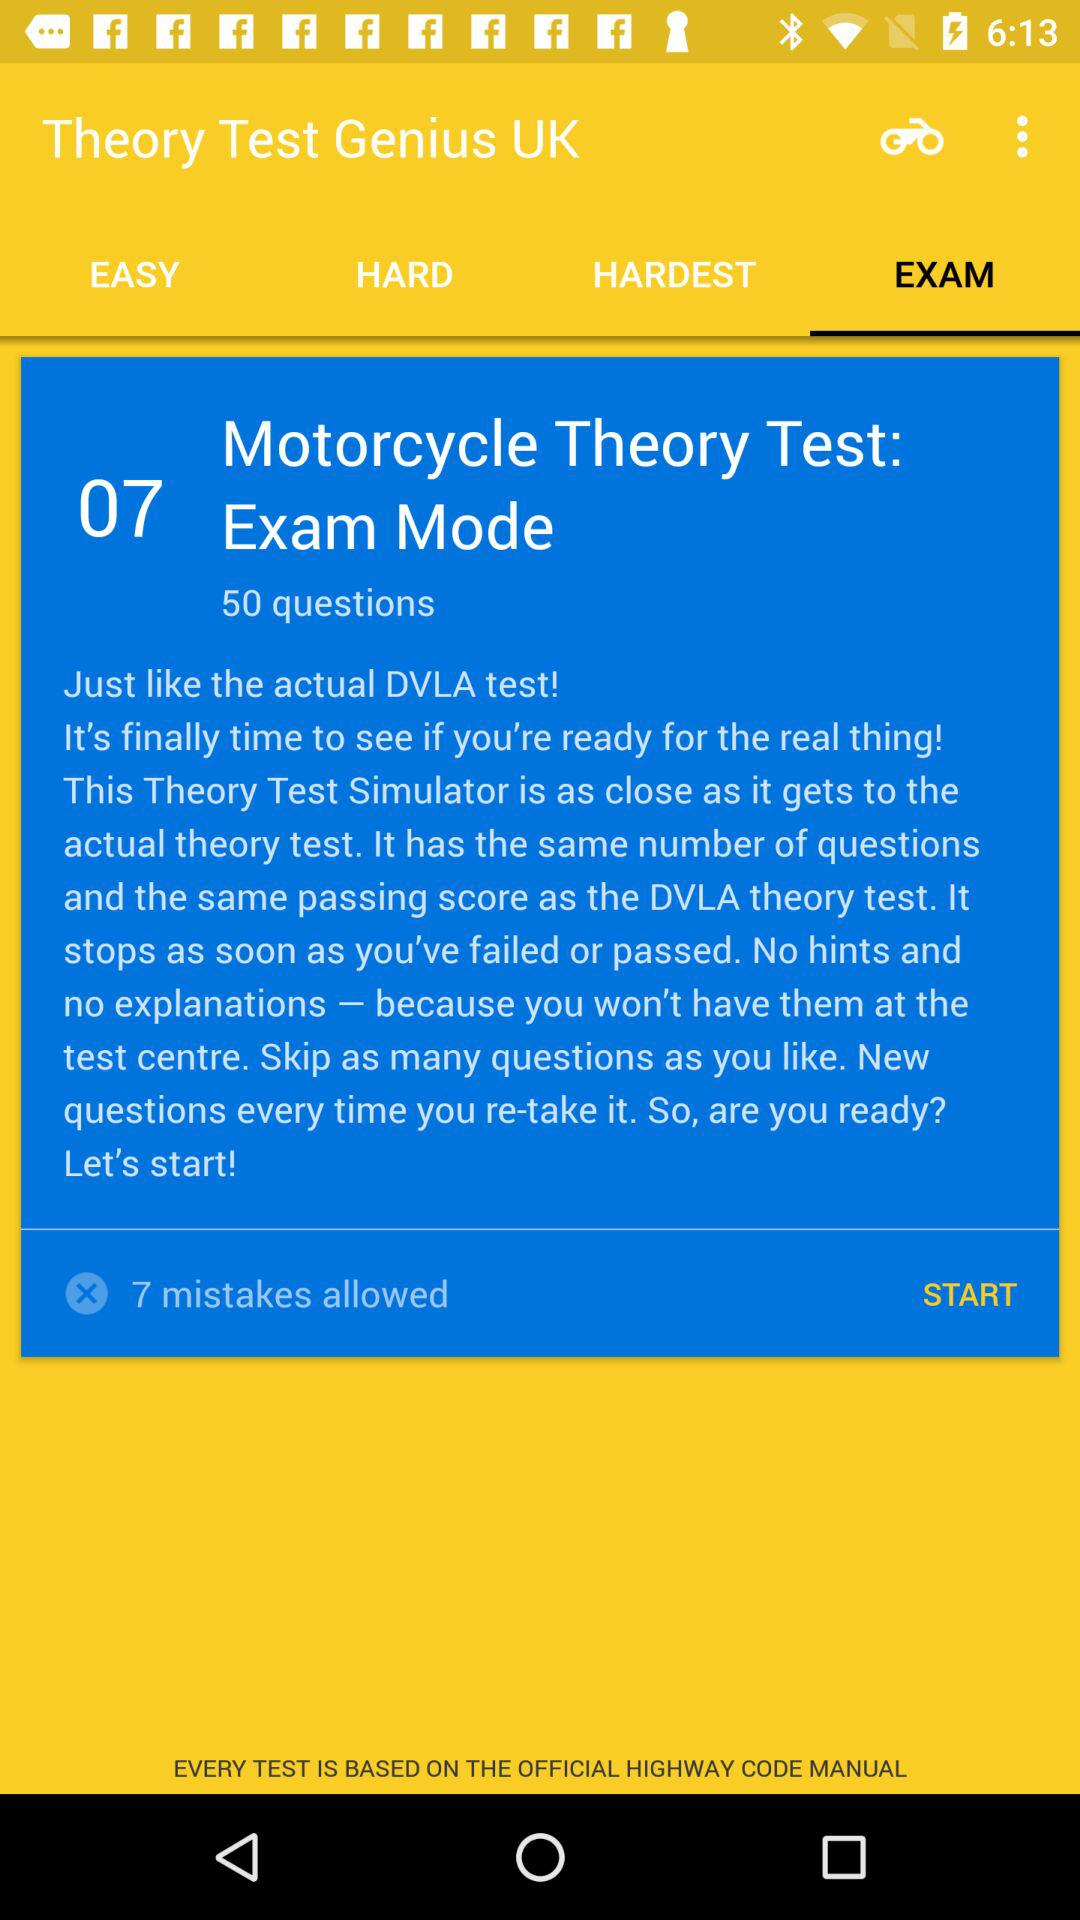Which tab is selected? The selected tab is "EXAM". 